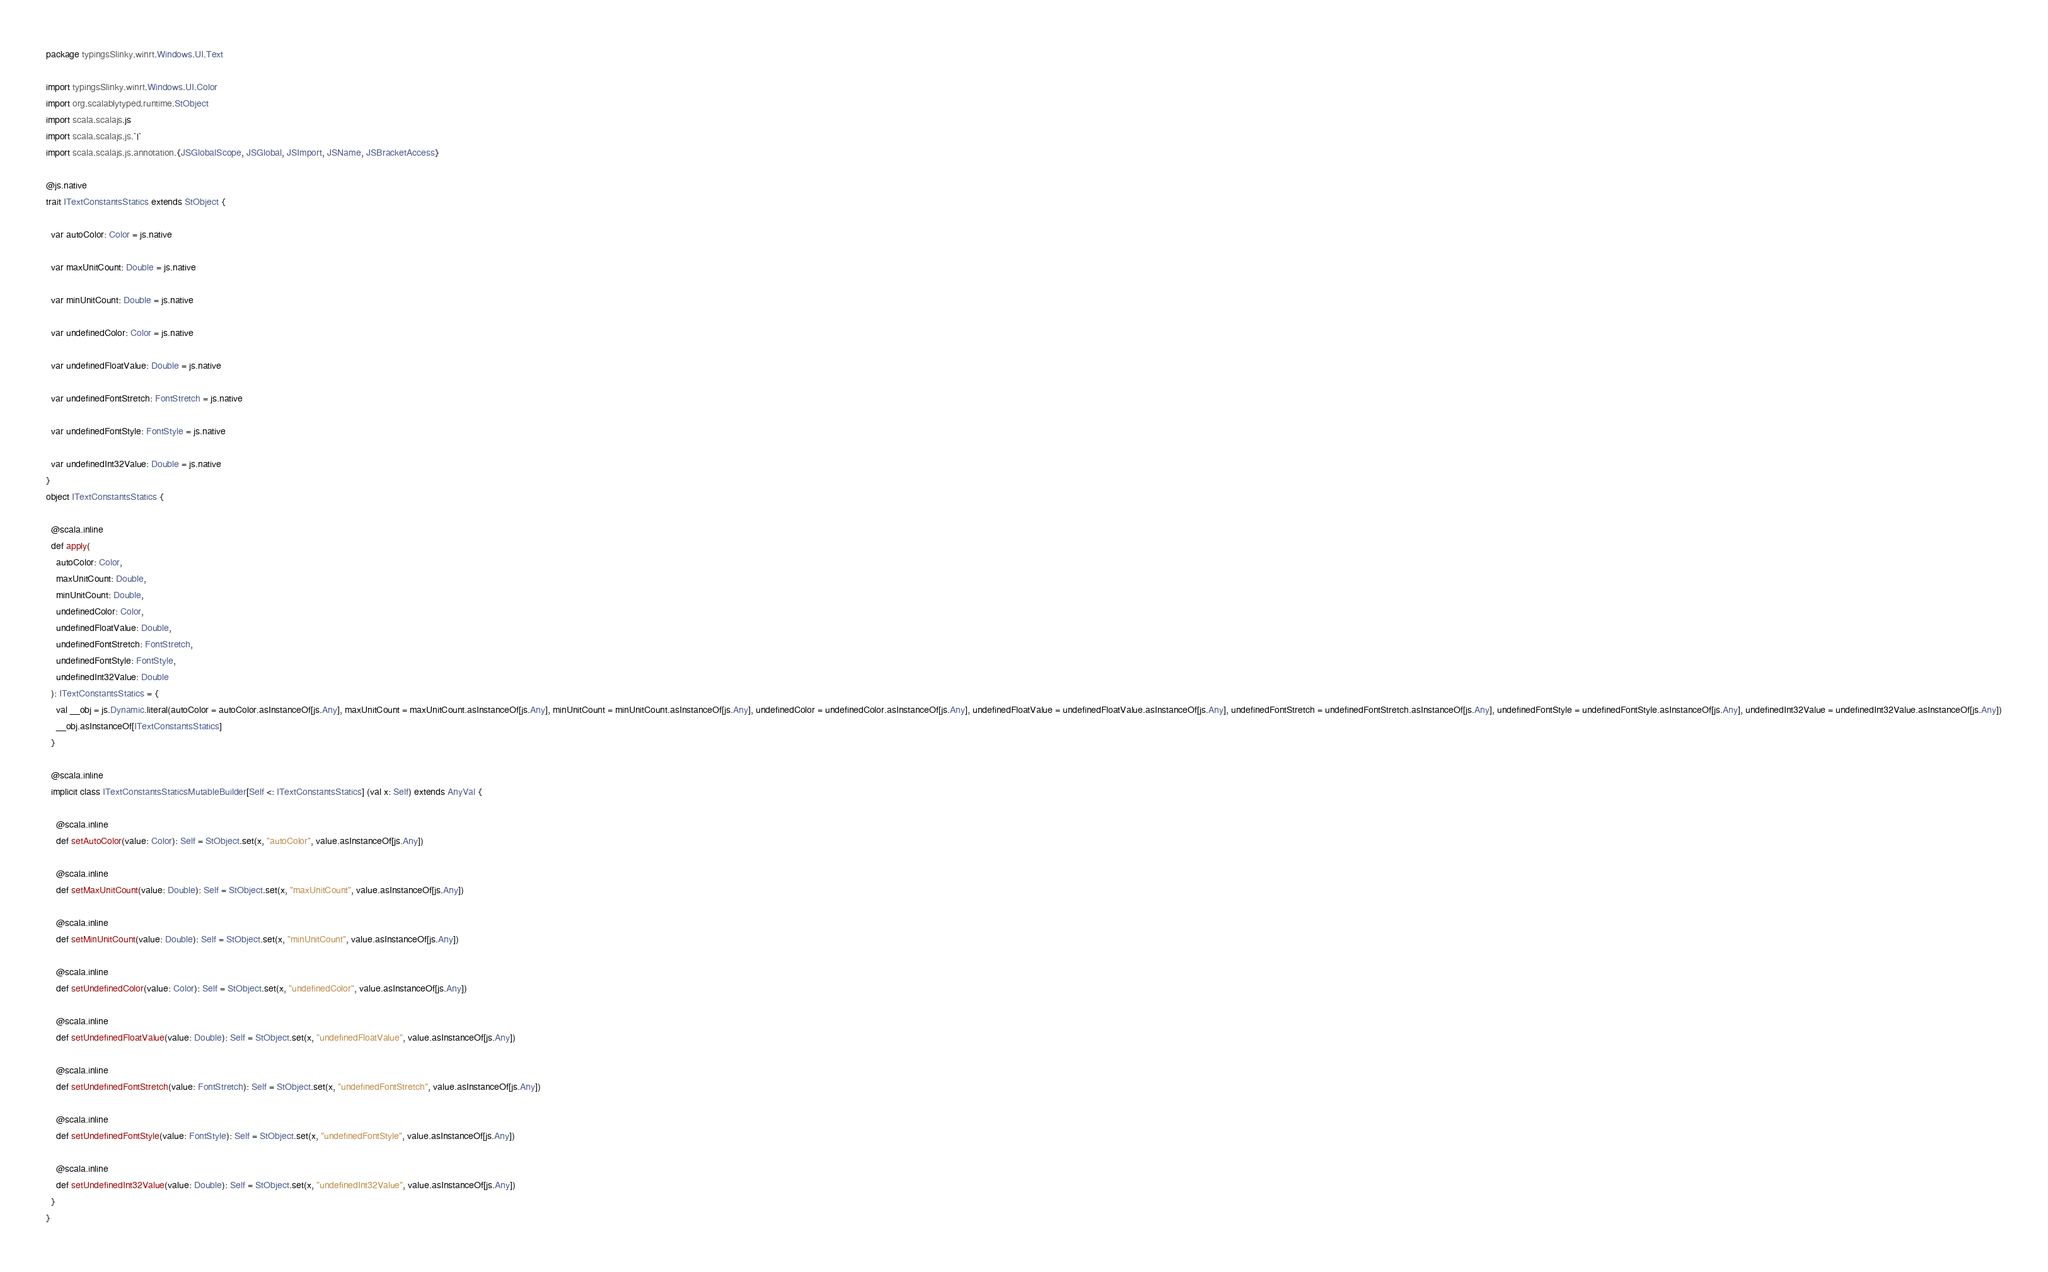<code> <loc_0><loc_0><loc_500><loc_500><_Scala_>package typingsSlinky.winrt.Windows.UI.Text

import typingsSlinky.winrt.Windows.UI.Color
import org.scalablytyped.runtime.StObject
import scala.scalajs.js
import scala.scalajs.js.`|`
import scala.scalajs.js.annotation.{JSGlobalScope, JSGlobal, JSImport, JSName, JSBracketAccess}

@js.native
trait ITextConstantsStatics extends StObject {
  
  var autoColor: Color = js.native
  
  var maxUnitCount: Double = js.native
  
  var minUnitCount: Double = js.native
  
  var undefinedColor: Color = js.native
  
  var undefinedFloatValue: Double = js.native
  
  var undefinedFontStretch: FontStretch = js.native
  
  var undefinedFontStyle: FontStyle = js.native
  
  var undefinedInt32Value: Double = js.native
}
object ITextConstantsStatics {
  
  @scala.inline
  def apply(
    autoColor: Color,
    maxUnitCount: Double,
    minUnitCount: Double,
    undefinedColor: Color,
    undefinedFloatValue: Double,
    undefinedFontStretch: FontStretch,
    undefinedFontStyle: FontStyle,
    undefinedInt32Value: Double
  ): ITextConstantsStatics = {
    val __obj = js.Dynamic.literal(autoColor = autoColor.asInstanceOf[js.Any], maxUnitCount = maxUnitCount.asInstanceOf[js.Any], minUnitCount = minUnitCount.asInstanceOf[js.Any], undefinedColor = undefinedColor.asInstanceOf[js.Any], undefinedFloatValue = undefinedFloatValue.asInstanceOf[js.Any], undefinedFontStretch = undefinedFontStretch.asInstanceOf[js.Any], undefinedFontStyle = undefinedFontStyle.asInstanceOf[js.Any], undefinedInt32Value = undefinedInt32Value.asInstanceOf[js.Any])
    __obj.asInstanceOf[ITextConstantsStatics]
  }
  
  @scala.inline
  implicit class ITextConstantsStaticsMutableBuilder[Self <: ITextConstantsStatics] (val x: Self) extends AnyVal {
    
    @scala.inline
    def setAutoColor(value: Color): Self = StObject.set(x, "autoColor", value.asInstanceOf[js.Any])
    
    @scala.inline
    def setMaxUnitCount(value: Double): Self = StObject.set(x, "maxUnitCount", value.asInstanceOf[js.Any])
    
    @scala.inline
    def setMinUnitCount(value: Double): Self = StObject.set(x, "minUnitCount", value.asInstanceOf[js.Any])
    
    @scala.inline
    def setUndefinedColor(value: Color): Self = StObject.set(x, "undefinedColor", value.asInstanceOf[js.Any])
    
    @scala.inline
    def setUndefinedFloatValue(value: Double): Self = StObject.set(x, "undefinedFloatValue", value.asInstanceOf[js.Any])
    
    @scala.inline
    def setUndefinedFontStretch(value: FontStretch): Self = StObject.set(x, "undefinedFontStretch", value.asInstanceOf[js.Any])
    
    @scala.inline
    def setUndefinedFontStyle(value: FontStyle): Self = StObject.set(x, "undefinedFontStyle", value.asInstanceOf[js.Any])
    
    @scala.inline
    def setUndefinedInt32Value(value: Double): Self = StObject.set(x, "undefinedInt32Value", value.asInstanceOf[js.Any])
  }
}
</code> 